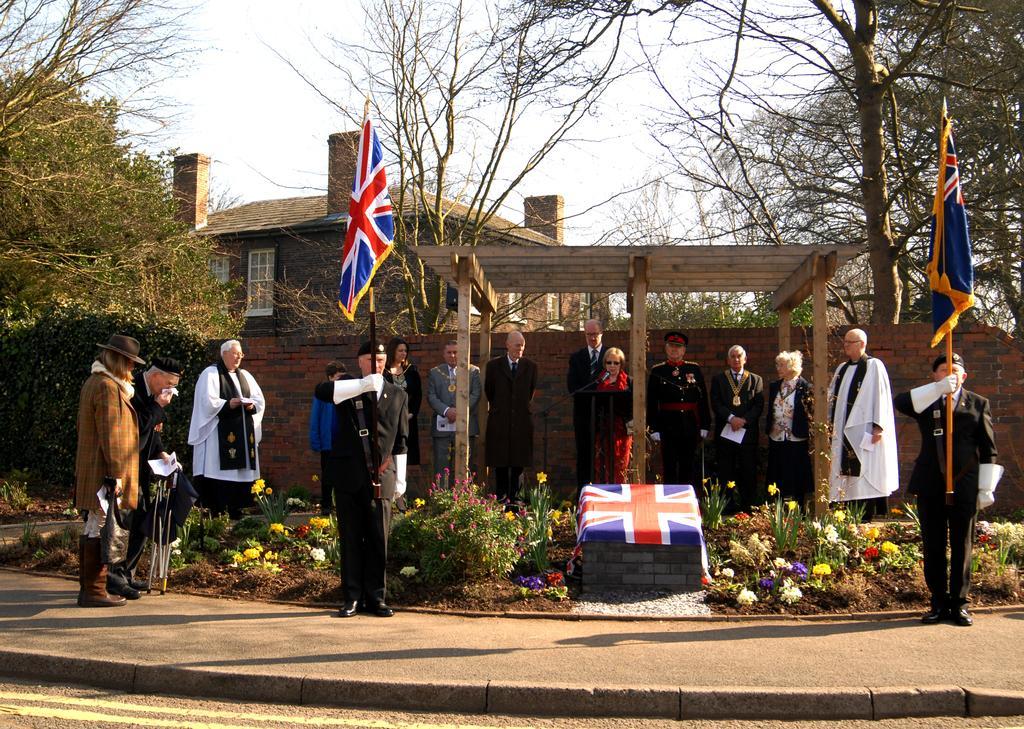How would you summarize this image in a sentence or two? In this image there are group of persons standing. In the center there are persons standing and holding flags, there are flowers and there is a shelter. In the background there are trees, there is a wall and there is a house. 